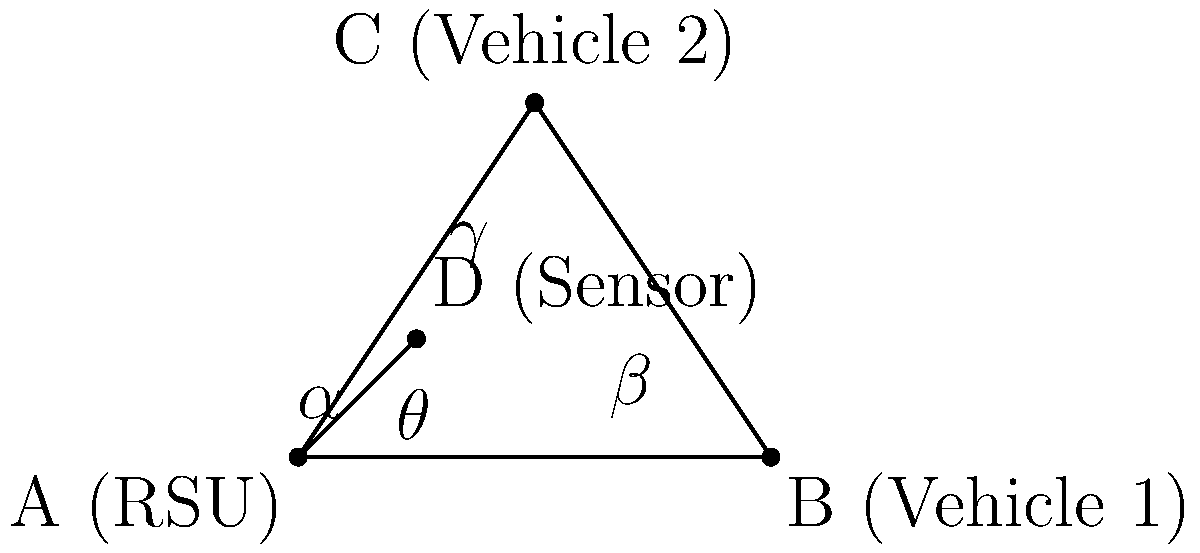In a Vehicle-to-Infrastructure (V2I) communication network, a Roadside Unit (RSU) is positioned at point A, while two vehicles are located at points B and C. An additional sensor is placed at point D. Given that $\angle BAC = 53°$, $\angle ABC = 37°$, and $\angle DAB = 45°$, calculate the angle $\theta$ between the sensor (D) and Vehicle 2 (C) as observed from the RSU (A). To find angle $\theta$ (DAC), we can follow these steps:

1) First, let's identify the known angles:
   $\alpha = \angle DAB = 45°$
   $\angle BAC = 53°$
   $\angle ABC = 37°$

2) In triangle ABC, we can find $\angle BCA$:
   $\angle BCA = 180° - \angle BAC - \angle ABC = 180° - 53° - 37° = 90°$

3) Let's define $\beta = \angle CAB$ and $\gamma = \angle DAC$ (our target angle $\theta$)

4) We know that $\alpha + \beta + \gamma = \angle BAC = 53°$

5) We can find $\beta$:
   $\beta = \angle CAB = 180° - \angle ABC - \angle BCA = 180° - 37° - 90° = 53°$

6) Now we can solve for $\gamma$ (which is our target angle $\theta$):
   $\alpha + \beta + \gamma = 53°$
   $45° + 53° + \gamma = 53°$
   $\gamma = 53° - 45° - 53° = -45°$

7) Since angles are typically expressed as positive values, we take the absolute value:
   $\theta = |\gamma| = 45°$

Therefore, the angle $\theta$ between the sensor (D) and Vehicle 2 (C) as observed from the RSU (A) is 45°.
Answer: $45°$ 